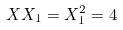<formula> <loc_0><loc_0><loc_500><loc_500>X X _ { 1 } = X _ { 1 } ^ { 2 } = 4</formula> 